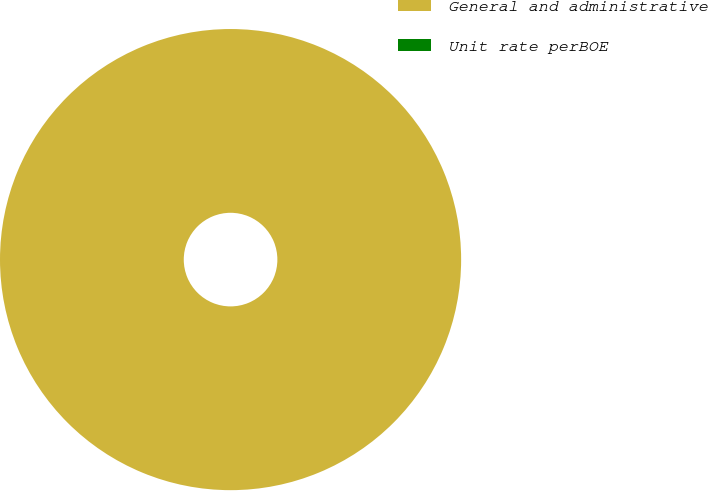Convert chart to OTSL. <chart><loc_0><loc_0><loc_500><loc_500><pie_chart><fcel>General and administrative<fcel>Unit rate perBOE<nl><fcel>100.0%<fcel>0.0%<nl></chart> 